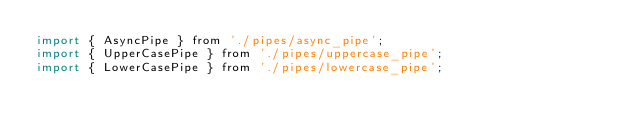Convert code to text. <code><loc_0><loc_0><loc_500><loc_500><_JavaScript_>import { AsyncPipe } from './pipes/async_pipe';
import { UpperCasePipe } from './pipes/uppercase_pipe';
import { LowerCasePipe } from './pipes/lowercase_pipe';</code> 